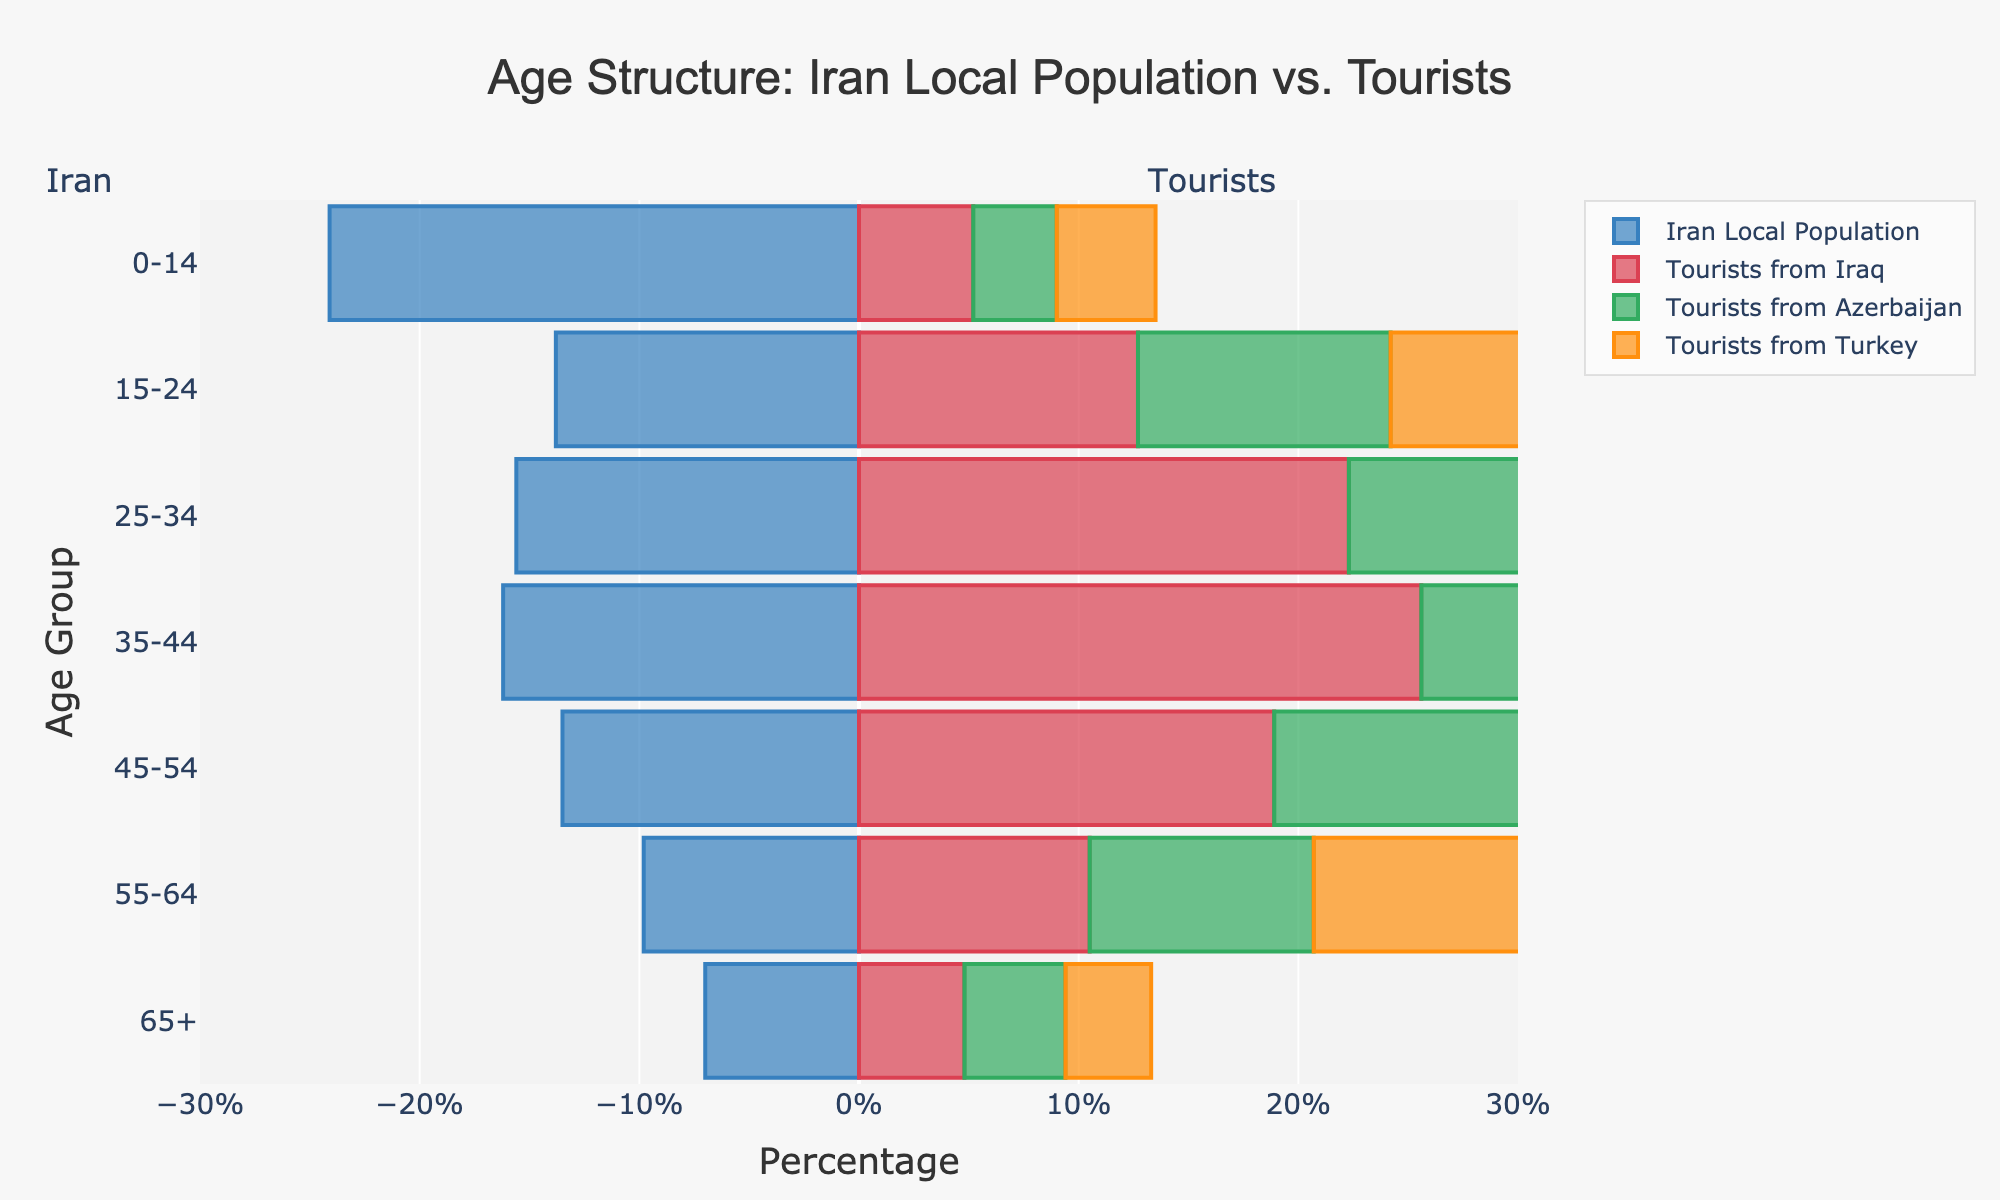What's the title of the figure? The title is found at the top center of the figure. It reads "Age Structure: Iran Local Population vs. Tourists".
Answer: Age Structure: Iran Local Population vs. Tourists Which age group has the highest percentage of local population in Iran? To find the highest percentage of the local population, we examine the widest bar specifically for "Iran Local Population (%)". The age group "0-14" has the highest value at 24.1%.
Answer: 0-14 How does the percentage of tourists from Turkey in the 35-44 age group compare to that of tourists from Iraq in the same age group? To compare the percentages, we look at the bars for the 35-44 age group for both countries. Tourists from Turkey have a percentage of 25.9% while tourists from Iraq have 25.6%.
Answer: Tourists from Turkey have a slightly higher percentage In which age group do tourists from Azerbaijan have the highest percentage, and what is that percentage? We look for the widest bar labeled "Tourists from Azerbaijan (%)". The 35-44 age group has the highest percentage at 26.3%.
Answer: 35-44, 26.3% What is the difference in the percentage of tourists from Iraq between the 25-34 age group and the 65+ age group? To find the difference, subtract the percentage of the 65+ age group (4.8%) from the 25-34 age group (22.3%). 22.3% - 4.8% = 17.5%.
Answer: 17.5% Among the presented countries, for which age group is there the largest variance in tourist percentages? Variance can be observed where the bars are widest and vary greatly in length for a certain age group. For the 35-44 age group, the percentages are: Iraq (25.6%), Azerbaijan (26.3%), Turkey (25.9%), displaying large differences among groups.
Answer: 35-44 What is the overall trend of the local Iranian population percentage as age increases? By observing the bars from the 0-14 to 65+ age groups for "Iran Local Population (%)", one can see that the percentage generally decreases as age increases.
Answer: Decreasing How do the percentages of tourists from Iraq and Azerbaijan in the 45-54 age group compare? For the 45-54 age group, we compare the bars for "Tourists from Iraq (%)" and "Tourists from Azerbaijan (%)". Iraq has 18.9% and Azerbaijan has 19.5%.
Answer: Tourists from Azerbaijan have a slightly higher percentage 